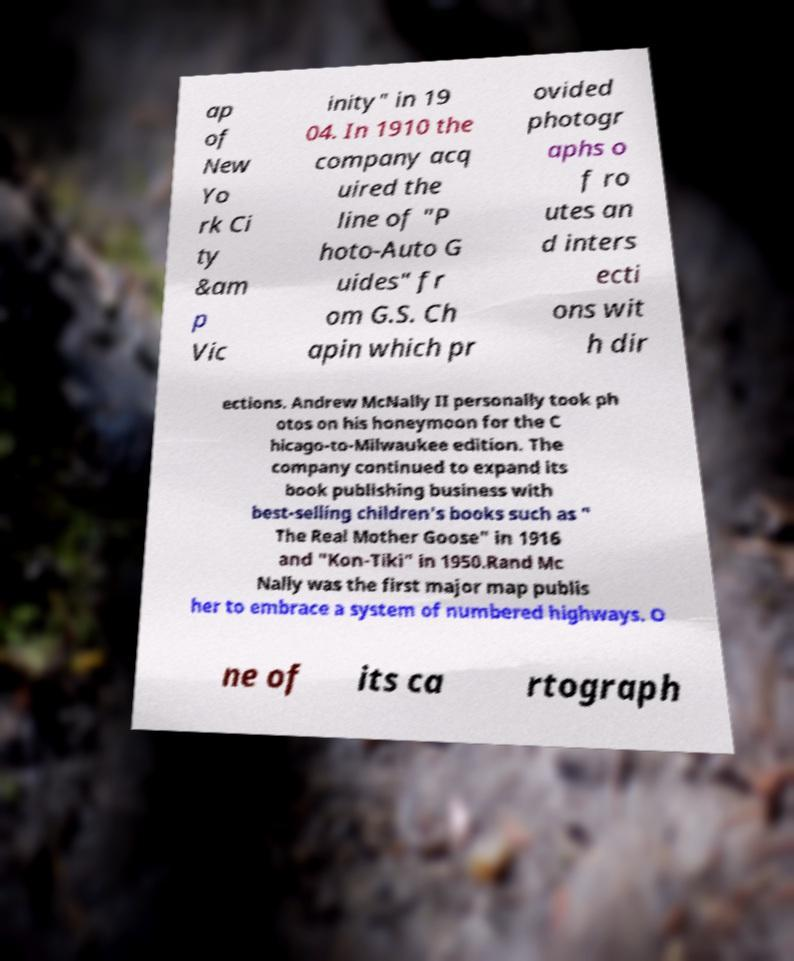Can you read and provide the text displayed in the image?This photo seems to have some interesting text. Can you extract and type it out for me? ap of New Yo rk Ci ty &am p Vic inity" in 19 04. In 1910 the company acq uired the line of "P hoto-Auto G uides" fr om G.S. Ch apin which pr ovided photogr aphs o f ro utes an d inters ecti ons wit h dir ections. Andrew McNally II personally took ph otos on his honeymoon for the C hicago-to-Milwaukee edition. The company continued to expand its book publishing business with best-selling children's books such as " The Real Mother Goose" in 1916 and "Kon-Tiki" in 1950.Rand Mc Nally was the first major map publis her to embrace a system of numbered highways. O ne of its ca rtograph 